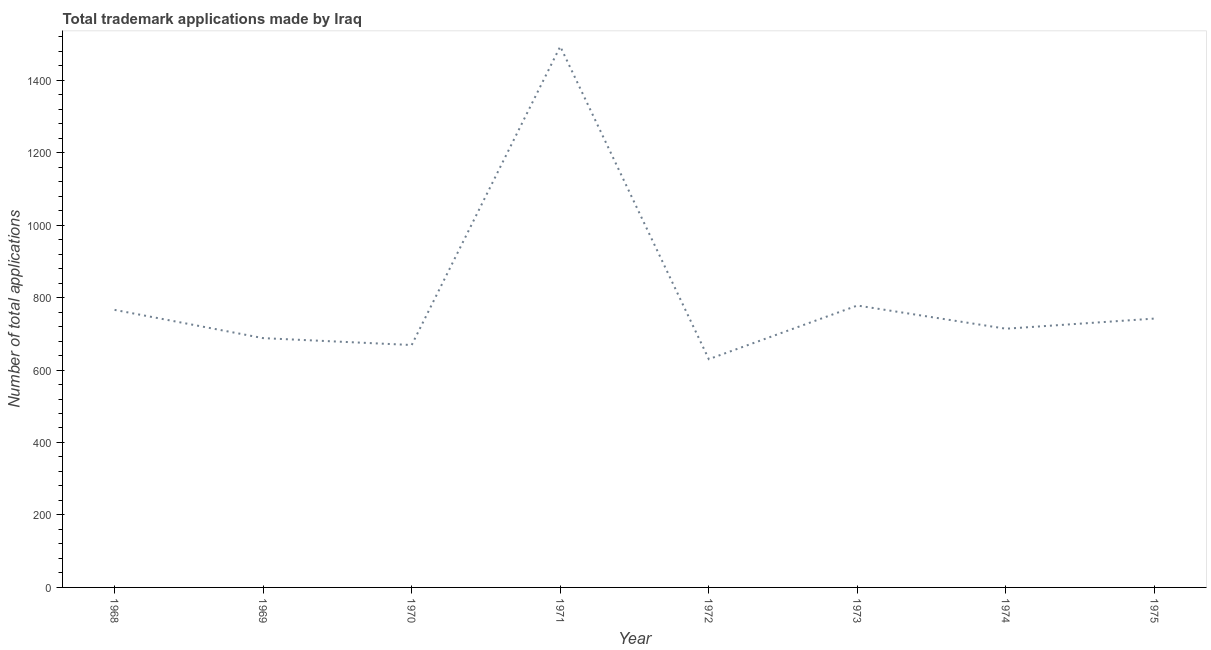What is the number of trademark applications in 1975?
Offer a very short reply. 742. Across all years, what is the maximum number of trademark applications?
Make the answer very short. 1493. Across all years, what is the minimum number of trademark applications?
Offer a terse response. 630. In which year was the number of trademark applications maximum?
Make the answer very short. 1971. What is the sum of the number of trademark applications?
Your response must be concise. 6480. What is the difference between the number of trademark applications in 1970 and 1973?
Give a very brief answer. -109. What is the average number of trademark applications per year?
Your answer should be very brief. 810. What is the median number of trademark applications?
Offer a very short reply. 728. In how many years, is the number of trademark applications greater than 1440 ?
Offer a terse response. 1. What is the ratio of the number of trademark applications in 1970 to that in 1974?
Make the answer very short. 0.94. Is the number of trademark applications in 1968 less than that in 1975?
Your answer should be very brief. No. What is the difference between the highest and the second highest number of trademark applications?
Keep it short and to the point. 715. What is the difference between the highest and the lowest number of trademark applications?
Provide a succinct answer. 863. Does the number of trademark applications monotonically increase over the years?
Give a very brief answer. No. How many lines are there?
Your answer should be compact. 1. How many years are there in the graph?
Ensure brevity in your answer.  8. Are the values on the major ticks of Y-axis written in scientific E-notation?
Your answer should be very brief. No. Does the graph contain any zero values?
Offer a very short reply. No. Does the graph contain grids?
Your answer should be very brief. No. What is the title of the graph?
Make the answer very short. Total trademark applications made by Iraq. What is the label or title of the X-axis?
Keep it short and to the point. Year. What is the label or title of the Y-axis?
Provide a succinct answer. Number of total applications. What is the Number of total applications in 1968?
Offer a terse response. 766. What is the Number of total applications in 1969?
Keep it short and to the point. 688. What is the Number of total applications in 1970?
Provide a succinct answer. 669. What is the Number of total applications of 1971?
Keep it short and to the point. 1493. What is the Number of total applications of 1972?
Your answer should be very brief. 630. What is the Number of total applications in 1973?
Your answer should be very brief. 778. What is the Number of total applications in 1974?
Your answer should be very brief. 714. What is the Number of total applications in 1975?
Your response must be concise. 742. What is the difference between the Number of total applications in 1968 and 1970?
Ensure brevity in your answer.  97. What is the difference between the Number of total applications in 1968 and 1971?
Your response must be concise. -727. What is the difference between the Number of total applications in 1968 and 1972?
Provide a succinct answer. 136. What is the difference between the Number of total applications in 1968 and 1974?
Ensure brevity in your answer.  52. What is the difference between the Number of total applications in 1968 and 1975?
Provide a short and direct response. 24. What is the difference between the Number of total applications in 1969 and 1971?
Your answer should be very brief. -805. What is the difference between the Number of total applications in 1969 and 1972?
Provide a short and direct response. 58. What is the difference between the Number of total applications in 1969 and 1973?
Make the answer very short. -90. What is the difference between the Number of total applications in 1969 and 1974?
Your response must be concise. -26. What is the difference between the Number of total applications in 1969 and 1975?
Give a very brief answer. -54. What is the difference between the Number of total applications in 1970 and 1971?
Offer a terse response. -824. What is the difference between the Number of total applications in 1970 and 1972?
Keep it short and to the point. 39. What is the difference between the Number of total applications in 1970 and 1973?
Make the answer very short. -109. What is the difference between the Number of total applications in 1970 and 1974?
Offer a terse response. -45. What is the difference between the Number of total applications in 1970 and 1975?
Provide a short and direct response. -73. What is the difference between the Number of total applications in 1971 and 1972?
Provide a short and direct response. 863. What is the difference between the Number of total applications in 1971 and 1973?
Offer a very short reply. 715. What is the difference between the Number of total applications in 1971 and 1974?
Give a very brief answer. 779. What is the difference between the Number of total applications in 1971 and 1975?
Keep it short and to the point. 751. What is the difference between the Number of total applications in 1972 and 1973?
Keep it short and to the point. -148. What is the difference between the Number of total applications in 1972 and 1974?
Ensure brevity in your answer.  -84. What is the difference between the Number of total applications in 1972 and 1975?
Give a very brief answer. -112. What is the difference between the Number of total applications in 1973 and 1975?
Your response must be concise. 36. What is the ratio of the Number of total applications in 1968 to that in 1969?
Keep it short and to the point. 1.11. What is the ratio of the Number of total applications in 1968 to that in 1970?
Provide a short and direct response. 1.15. What is the ratio of the Number of total applications in 1968 to that in 1971?
Your answer should be very brief. 0.51. What is the ratio of the Number of total applications in 1968 to that in 1972?
Provide a short and direct response. 1.22. What is the ratio of the Number of total applications in 1968 to that in 1973?
Your answer should be very brief. 0.98. What is the ratio of the Number of total applications in 1968 to that in 1974?
Your answer should be compact. 1.07. What is the ratio of the Number of total applications in 1968 to that in 1975?
Provide a succinct answer. 1.03. What is the ratio of the Number of total applications in 1969 to that in 1970?
Your response must be concise. 1.03. What is the ratio of the Number of total applications in 1969 to that in 1971?
Your answer should be very brief. 0.46. What is the ratio of the Number of total applications in 1969 to that in 1972?
Make the answer very short. 1.09. What is the ratio of the Number of total applications in 1969 to that in 1973?
Your answer should be compact. 0.88. What is the ratio of the Number of total applications in 1969 to that in 1974?
Give a very brief answer. 0.96. What is the ratio of the Number of total applications in 1969 to that in 1975?
Give a very brief answer. 0.93. What is the ratio of the Number of total applications in 1970 to that in 1971?
Offer a very short reply. 0.45. What is the ratio of the Number of total applications in 1970 to that in 1972?
Provide a short and direct response. 1.06. What is the ratio of the Number of total applications in 1970 to that in 1973?
Make the answer very short. 0.86. What is the ratio of the Number of total applications in 1970 to that in 1974?
Give a very brief answer. 0.94. What is the ratio of the Number of total applications in 1970 to that in 1975?
Keep it short and to the point. 0.9. What is the ratio of the Number of total applications in 1971 to that in 1972?
Your answer should be compact. 2.37. What is the ratio of the Number of total applications in 1971 to that in 1973?
Make the answer very short. 1.92. What is the ratio of the Number of total applications in 1971 to that in 1974?
Give a very brief answer. 2.09. What is the ratio of the Number of total applications in 1971 to that in 1975?
Give a very brief answer. 2.01. What is the ratio of the Number of total applications in 1972 to that in 1973?
Make the answer very short. 0.81. What is the ratio of the Number of total applications in 1972 to that in 1974?
Your answer should be compact. 0.88. What is the ratio of the Number of total applications in 1972 to that in 1975?
Offer a very short reply. 0.85. What is the ratio of the Number of total applications in 1973 to that in 1974?
Keep it short and to the point. 1.09. What is the ratio of the Number of total applications in 1973 to that in 1975?
Make the answer very short. 1.05. What is the ratio of the Number of total applications in 1974 to that in 1975?
Provide a succinct answer. 0.96. 